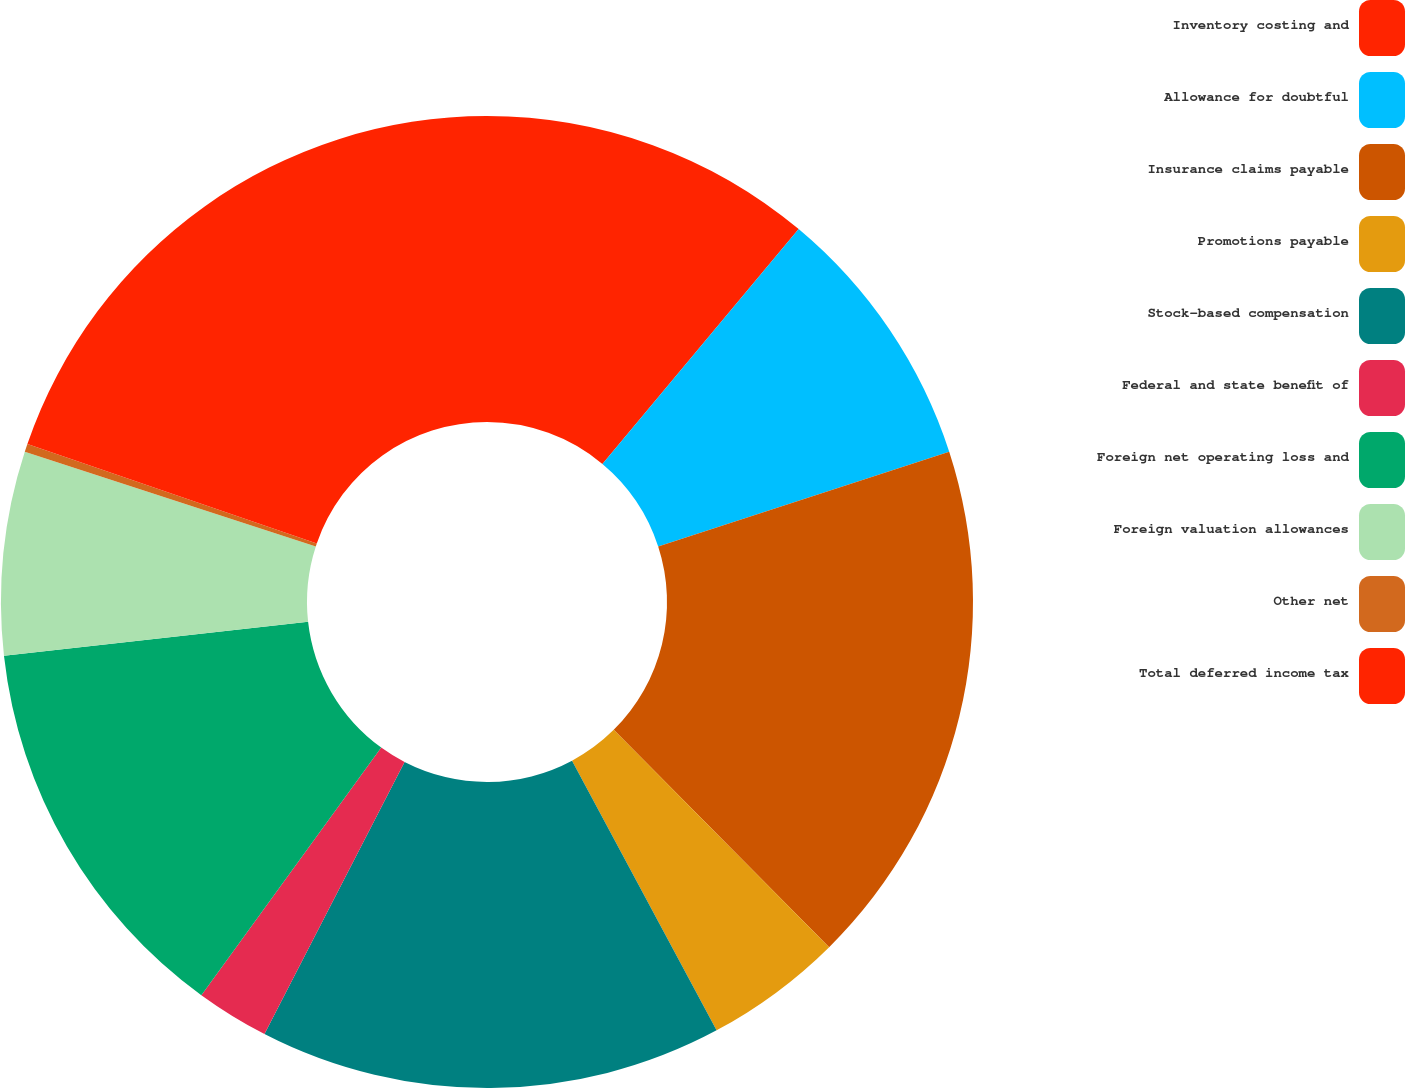Convert chart to OTSL. <chart><loc_0><loc_0><loc_500><loc_500><pie_chart><fcel>Inventory costing and<fcel>Allowance for doubtful<fcel>Insurance claims payable<fcel>Promotions payable<fcel>Stock-based compensation<fcel>Federal and state benefit of<fcel>Foreign net operating loss and<fcel>Foreign valuation allowances<fcel>Other net<fcel>Total deferred income tax<nl><fcel>11.08%<fcel>8.92%<fcel>17.57%<fcel>4.6%<fcel>15.4%<fcel>2.43%<fcel>13.24%<fcel>6.76%<fcel>0.27%<fcel>19.73%<nl></chart> 